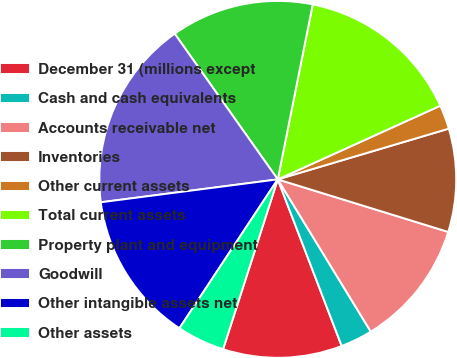<chart> <loc_0><loc_0><loc_500><loc_500><pie_chart><fcel>December 31 (millions except<fcel>Cash and cash equivalents<fcel>Accounts receivable net<fcel>Inventories<fcel>Other current assets<fcel>Total current assets<fcel>Property plant and equipment<fcel>Goodwill<fcel>Other intangible assets net<fcel>Other assets<nl><fcel>10.79%<fcel>2.9%<fcel>11.51%<fcel>9.35%<fcel>2.18%<fcel>15.09%<fcel>12.94%<fcel>17.25%<fcel>13.66%<fcel>4.33%<nl></chart> 